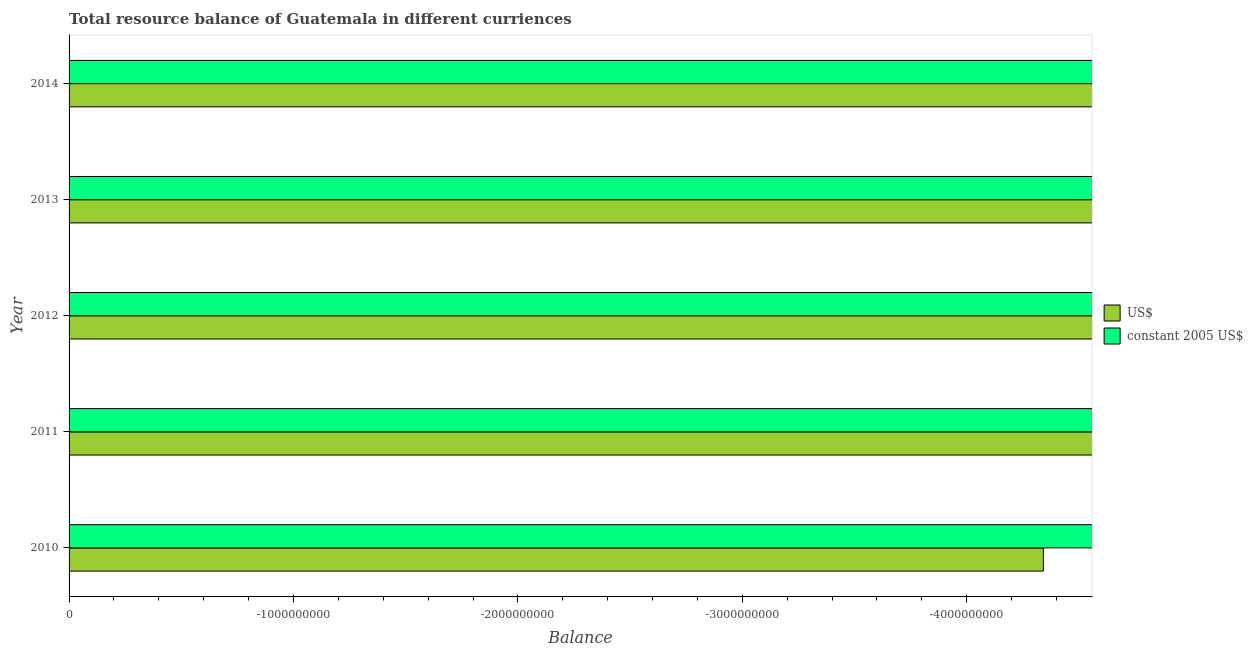How many different coloured bars are there?
Provide a short and direct response. 0. How many bars are there on the 5th tick from the bottom?
Keep it short and to the point. 0. In how many cases, is the number of bars for a given year not equal to the number of legend labels?
Provide a short and direct response. 5. What is the average resource balance in constant us$ per year?
Give a very brief answer. 0. In how many years, is the resource balance in constant us$ greater than -600000000 units?
Provide a succinct answer. 0. In how many years, is the resource balance in constant us$ greater than the average resource balance in constant us$ taken over all years?
Offer a terse response. 0. How many bars are there?
Your response must be concise. 0. Are all the bars in the graph horizontal?
Provide a succinct answer. Yes. What is the difference between two consecutive major ticks on the X-axis?
Your answer should be very brief. 1.00e+09. Does the graph contain any zero values?
Provide a short and direct response. Yes. Does the graph contain grids?
Offer a very short reply. No. Where does the legend appear in the graph?
Your answer should be very brief. Center right. How many legend labels are there?
Keep it short and to the point. 2. What is the title of the graph?
Provide a short and direct response. Total resource balance of Guatemala in different curriences. What is the label or title of the X-axis?
Your response must be concise. Balance. What is the Balance in US$ in 2010?
Make the answer very short. 0. What is the Balance of US$ in 2011?
Offer a very short reply. 0. What is the Balance of US$ in 2012?
Make the answer very short. 0. What is the Balance in constant 2005 US$ in 2012?
Your answer should be compact. 0. What is the Balance in US$ in 2013?
Your response must be concise. 0. What is the Balance of constant 2005 US$ in 2013?
Give a very brief answer. 0. What is the total Balance in US$ in the graph?
Offer a terse response. 0. What is the average Balance of constant 2005 US$ per year?
Make the answer very short. 0. 